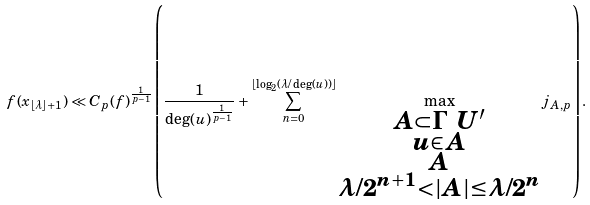Convert formula to latex. <formula><loc_0><loc_0><loc_500><loc_500>f ( x _ { \lfloor \lambda \rfloor + 1 } ) \ll C _ { p } ( f ) ^ { \frac { 1 } { p - 1 } } \left ( \frac { 1 } { \deg ( u ) ^ { \frac { 1 } { p - 1 } } } + \sum _ { n = 0 } ^ { \lfloor \log _ { 2 } ( \lambda / \deg ( u ) ) \rfloor } \max _ { \substack { A \subset \Gamma \ U ^ { \prime } \\ u \in A \\ A \\ \lambda / 2 ^ { n + 1 } < | A | \leq \lambda / 2 ^ { n } } } j _ { A , p } \right ) .</formula> 